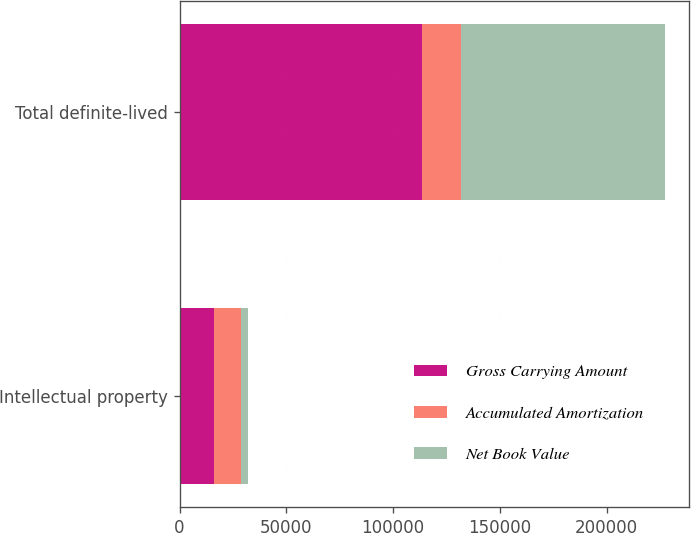Convert chart to OTSL. <chart><loc_0><loc_0><loc_500><loc_500><stacked_bar_chart><ecel><fcel>Intellectual property<fcel>Total definite-lived<nl><fcel>Gross Carrying Amount<fcel>15931<fcel>113627<nl><fcel>Accumulated Amortization<fcel>12943<fcel>18192<nl><fcel>Net Book Value<fcel>2988<fcel>95435<nl></chart> 